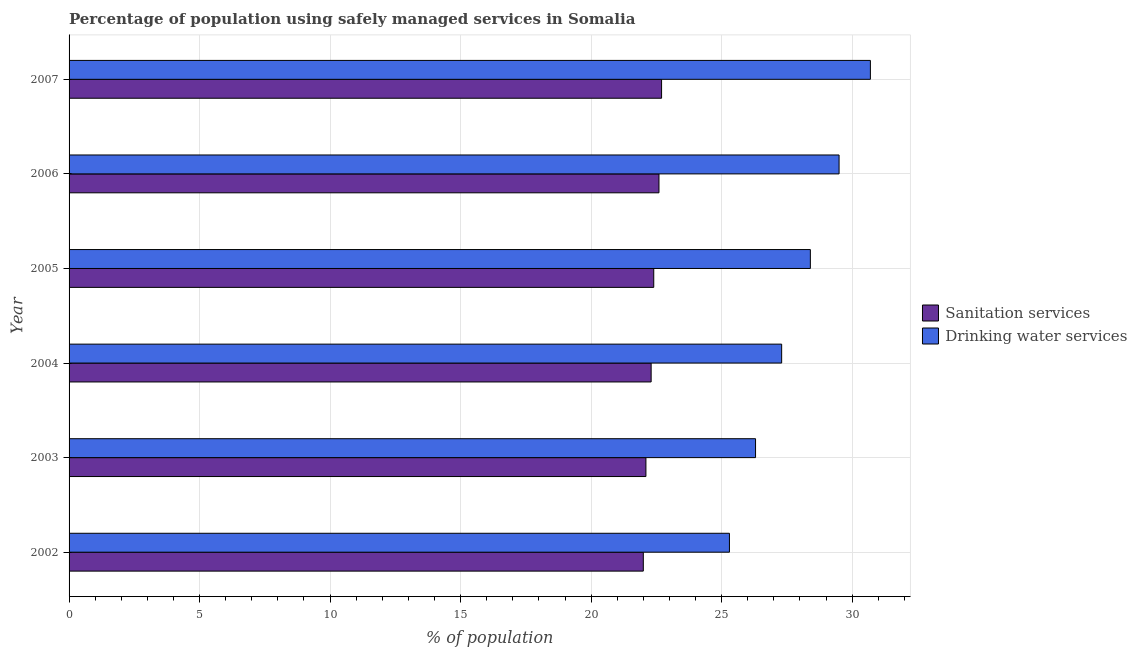How many different coloured bars are there?
Keep it short and to the point. 2. How many groups of bars are there?
Keep it short and to the point. 6. Are the number of bars per tick equal to the number of legend labels?
Provide a succinct answer. Yes. Are the number of bars on each tick of the Y-axis equal?
Keep it short and to the point. Yes. In how many cases, is the number of bars for a given year not equal to the number of legend labels?
Keep it short and to the point. 0. What is the percentage of population who used sanitation services in 2004?
Offer a very short reply. 22.3. Across all years, what is the maximum percentage of population who used drinking water services?
Offer a terse response. 30.7. Across all years, what is the minimum percentage of population who used drinking water services?
Keep it short and to the point. 25.3. In which year was the percentage of population who used sanitation services maximum?
Provide a short and direct response. 2007. What is the total percentage of population who used drinking water services in the graph?
Your answer should be compact. 167.5. What is the difference between the percentage of population who used drinking water services in 2006 and the percentage of population who used sanitation services in 2007?
Offer a terse response. 6.8. What is the average percentage of population who used sanitation services per year?
Provide a short and direct response. 22.35. In the year 2006, what is the difference between the percentage of population who used drinking water services and percentage of population who used sanitation services?
Your response must be concise. 6.9. In how many years, is the percentage of population who used drinking water services greater than 13 %?
Your answer should be compact. 6. Is the percentage of population who used drinking water services in 2003 less than that in 2005?
Keep it short and to the point. Yes. Is the difference between the percentage of population who used drinking water services in 2004 and 2005 greater than the difference between the percentage of population who used sanitation services in 2004 and 2005?
Offer a terse response. No. Is the sum of the percentage of population who used sanitation services in 2002 and 2006 greater than the maximum percentage of population who used drinking water services across all years?
Make the answer very short. Yes. What does the 2nd bar from the top in 2007 represents?
Your answer should be very brief. Sanitation services. What does the 2nd bar from the bottom in 2004 represents?
Offer a terse response. Drinking water services. Are all the bars in the graph horizontal?
Ensure brevity in your answer.  Yes. What is the difference between two consecutive major ticks on the X-axis?
Give a very brief answer. 5. Are the values on the major ticks of X-axis written in scientific E-notation?
Offer a very short reply. No. Does the graph contain grids?
Give a very brief answer. Yes. What is the title of the graph?
Give a very brief answer. Percentage of population using safely managed services in Somalia. Does "Net National savings" appear as one of the legend labels in the graph?
Keep it short and to the point. No. What is the label or title of the X-axis?
Make the answer very short. % of population. What is the label or title of the Y-axis?
Provide a succinct answer. Year. What is the % of population of Sanitation services in 2002?
Give a very brief answer. 22. What is the % of population in Drinking water services in 2002?
Provide a succinct answer. 25.3. What is the % of population of Sanitation services in 2003?
Your answer should be compact. 22.1. What is the % of population in Drinking water services in 2003?
Keep it short and to the point. 26.3. What is the % of population in Sanitation services in 2004?
Make the answer very short. 22.3. What is the % of population in Drinking water services in 2004?
Your response must be concise. 27.3. What is the % of population in Sanitation services in 2005?
Keep it short and to the point. 22.4. What is the % of population of Drinking water services in 2005?
Your response must be concise. 28.4. What is the % of population of Sanitation services in 2006?
Offer a very short reply. 22.6. What is the % of population of Drinking water services in 2006?
Offer a very short reply. 29.5. What is the % of population in Sanitation services in 2007?
Your response must be concise. 22.7. What is the % of population in Drinking water services in 2007?
Your answer should be very brief. 30.7. Across all years, what is the maximum % of population in Sanitation services?
Make the answer very short. 22.7. Across all years, what is the maximum % of population of Drinking water services?
Ensure brevity in your answer.  30.7. Across all years, what is the minimum % of population in Sanitation services?
Make the answer very short. 22. Across all years, what is the minimum % of population in Drinking water services?
Offer a very short reply. 25.3. What is the total % of population of Sanitation services in the graph?
Keep it short and to the point. 134.1. What is the total % of population of Drinking water services in the graph?
Your answer should be very brief. 167.5. What is the difference between the % of population of Sanitation services in 2002 and that in 2004?
Offer a terse response. -0.3. What is the difference between the % of population in Sanitation services in 2002 and that in 2005?
Ensure brevity in your answer.  -0.4. What is the difference between the % of population in Drinking water services in 2002 and that in 2005?
Your answer should be very brief. -3.1. What is the difference between the % of population in Sanitation services in 2002 and that in 2006?
Ensure brevity in your answer.  -0.6. What is the difference between the % of population in Sanitation services in 2003 and that in 2004?
Provide a succinct answer. -0.2. What is the difference between the % of population of Sanitation services in 2003 and that in 2005?
Provide a succinct answer. -0.3. What is the difference between the % of population in Sanitation services in 2003 and that in 2006?
Your response must be concise. -0.5. What is the difference between the % of population in Sanitation services in 2003 and that in 2007?
Keep it short and to the point. -0.6. What is the difference between the % of population in Sanitation services in 2004 and that in 2005?
Ensure brevity in your answer.  -0.1. What is the difference between the % of population in Drinking water services in 2004 and that in 2005?
Provide a succinct answer. -1.1. What is the difference between the % of population in Drinking water services in 2004 and that in 2006?
Ensure brevity in your answer.  -2.2. What is the difference between the % of population in Drinking water services in 2004 and that in 2007?
Ensure brevity in your answer.  -3.4. What is the difference between the % of population of Sanitation services in 2005 and that in 2006?
Offer a very short reply. -0.2. What is the difference between the % of population of Sanitation services in 2005 and that in 2007?
Make the answer very short. -0.3. What is the difference between the % of population in Sanitation services in 2002 and the % of population in Drinking water services in 2003?
Ensure brevity in your answer.  -4.3. What is the difference between the % of population of Sanitation services in 2002 and the % of population of Drinking water services in 2007?
Make the answer very short. -8.7. What is the difference between the % of population in Sanitation services in 2003 and the % of population in Drinking water services in 2004?
Offer a terse response. -5.2. What is the difference between the % of population of Sanitation services in 2003 and the % of population of Drinking water services in 2007?
Your answer should be very brief. -8.6. What is the difference between the % of population in Sanitation services in 2004 and the % of population in Drinking water services in 2005?
Give a very brief answer. -6.1. What is the difference between the % of population of Sanitation services in 2004 and the % of population of Drinking water services in 2006?
Ensure brevity in your answer.  -7.2. What is the difference between the % of population in Sanitation services in 2004 and the % of population in Drinking water services in 2007?
Your answer should be very brief. -8.4. What is the difference between the % of population of Sanitation services in 2006 and the % of population of Drinking water services in 2007?
Give a very brief answer. -8.1. What is the average % of population in Sanitation services per year?
Provide a short and direct response. 22.35. What is the average % of population of Drinking water services per year?
Your response must be concise. 27.92. In the year 2005, what is the difference between the % of population in Sanitation services and % of population in Drinking water services?
Keep it short and to the point. -6. In the year 2007, what is the difference between the % of population in Sanitation services and % of population in Drinking water services?
Ensure brevity in your answer.  -8. What is the ratio of the % of population in Sanitation services in 2002 to that in 2003?
Ensure brevity in your answer.  1. What is the ratio of the % of population of Sanitation services in 2002 to that in 2004?
Your response must be concise. 0.99. What is the ratio of the % of population of Drinking water services in 2002 to that in 2004?
Offer a terse response. 0.93. What is the ratio of the % of population of Sanitation services in 2002 to that in 2005?
Provide a succinct answer. 0.98. What is the ratio of the % of population in Drinking water services in 2002 to that in 2005?
Provide a short and direct response. 0.89. What is the ratio of the % of population of Sanitation services in 2002 to that in 2006?
Keep it short and to the point. 0.97. What is the ratio of the % of population of Drinking water services in 2002 to that in 2006?
Offer a very short reply. 0.86. What is the ratio of the % of population of Sanitation services in 2002 to that in 2007?
Make the answer very short. 0.97. What is the ratio of the % of population of Drinking water services in 2002 to that in 2007?
Offer a terse response. 0.82. What is the ratio of the % of population in Drinking water services in 2003 to that in 2004?
Give a very brief answer. 0.96. What is the ratio of the % of population of Sanitation services in 2003 to that in 2005?
Ensure brevity in your answer.  0.99. What is the ratio of the % of population in Drinking water services in 2003 to that in 2005?
Provide a succinct answer. 0.93. What is the ratio of the % of population in Sanitation services in 2003 to that in 2006?
Keep it short and to the point. 0.98. What is the ratio of the % of population of Drinking water services in 2003 to that in 2006?
Offer a very short reply. 0.89. What is the ratio of the % of population in Sanitation services in 2003 to that in 2007?
Make the answer very short. 0.97. What is the ratio of the % of population of Drinking water services in 2003 to that in 2007?
Give a very brief answer. 0.86. What is the ratio of the % of population in Drinking water services in 2004 to that in 2005?
Give a very brief answer. 0.96. What is the ratio of the % of population of Sanitation services in 2004 to that in 2006?
Make the answer very short. 0.99. What is the ratio of the % of population of Drinking water services in 2004 to that in 2006?
Offer a very short reply. 0.93. What is the ratio of the % of population in Sanitation services in 2004 to that in 2007?
Keep it short and to the point. 0.98. What is the ratio of the % of population in Drinking water services in 2004 to that in 2007?
Ensure brevity in your answer.  0.89. What is the ratio of the % of population of Drinking water services in 2005 to that in 2006?
Give a very brief answer. 0.96. What is the ratio of the % of population in Sanitation services in 2005 to that in 2007?
Your answer should be compact. 0.99. What is the ratio of the % of population of Drinking water services in 2005 to that in 2007?
Your response must be concise. 0.93. What is the ratio of the % of population of Drinking water services in 2006 to that in 2007?
Offer a very short reply. 0.96. What is the difference between the highest and the lowest % of population of Sanitation services?
Ensure brevity in your answer.  0.7. 